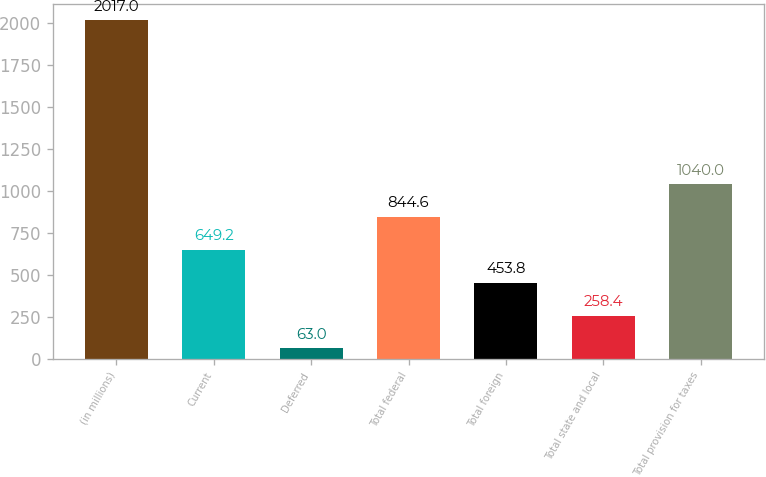<chart> <loc_0><loc_0><loc_500><loc_500><bar_chart><fcel>(in millions)<fcel>Current<fcel>Deferred<fcel>Total federal<fcel>Total foreign<fcel>Total state and local<fcel>Total provision for taxes<nl><fcel>2017<fcel>649.2<fcel>63<fcel>844.6<fcel>453.8<fcel>258.4<fcel>1040<nl></chart> 